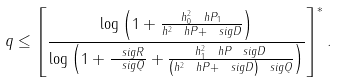Convert formula to latex. <formula><loc_0><loc_0><loc_500><loc_500>q \leq \left [ \frac { \log \left ( 1 + \frac { h _ { 0 } ^ { 2 } \ h P _ { 1 } } { h ^ { 2 } \ h P + \ s i g D } \right ) } { \log \left ( 1 + \frac { \ s i g R } { \ s i g Q } + \frac { h _ { 1 } ^ { 2 } \ h P \ s i g D } { \left ( h ^ { 2 } \ h P + \ s i g D \right ) \ s i g Q } \right ) } \right ] ^ { * } .</formula> 